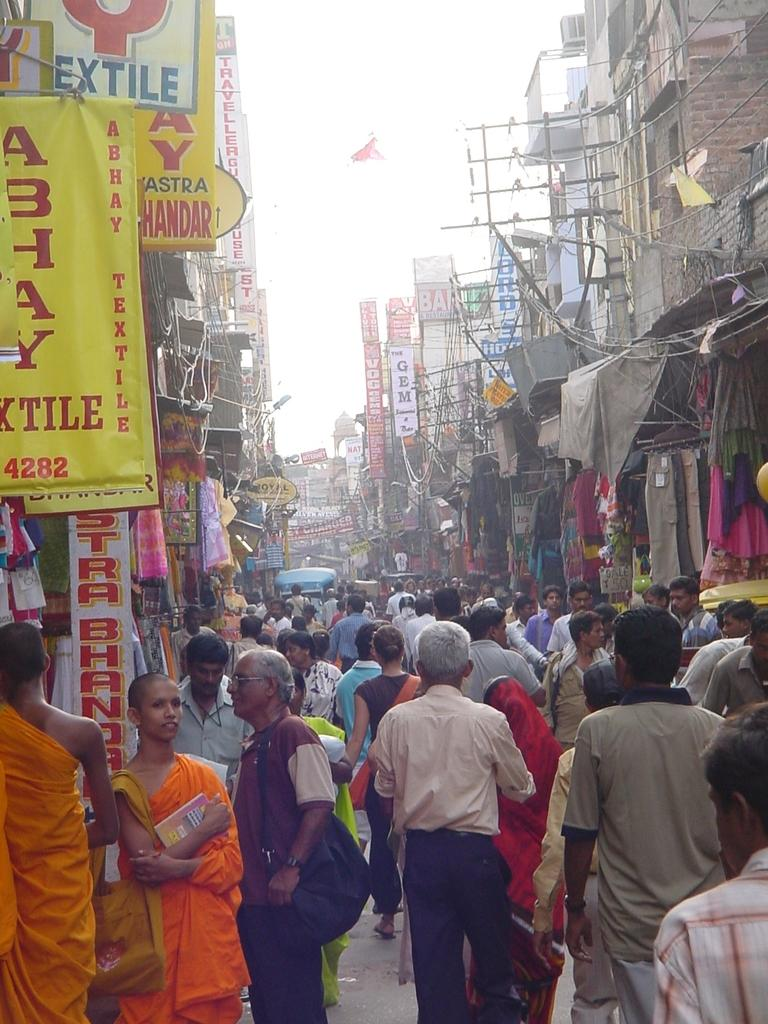What are the people in the image doing? The people in the image are standing on the road. What can be seen in the background of the image? There are buildings in the image. What type of establishments are present in the image? There are shops in the image. Can you see any clams being used as bait in the image? There are no clams or bait present in the image. Is there an airplane visible in the image? There is no airplane present in the image. 